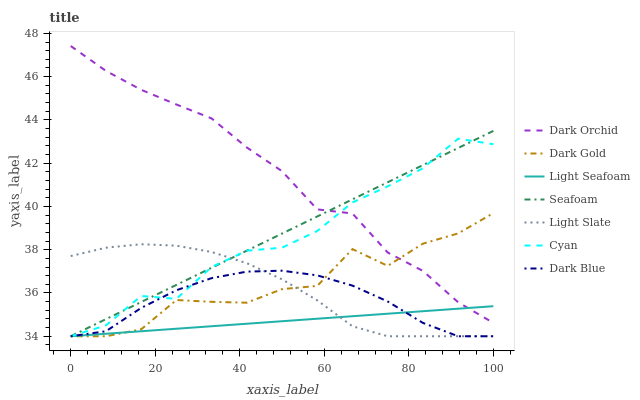Does Light Seafoam have the minimum area under the curve?
Answer yes or no. Yes. Does Dark Orchid have the maximum area under the curve?
Answer yes or no. Yes. Does Light Slate have the minimum area under the curve?
Answer yes or no. No. Does Light Slate have the maximum area under the curve?
Answer yes or no. No. Is Seafoam the smoothest?
Answer yes or no. Yes. Is Dark Gold the roughest?
Answer yes or no. Yes. Is Light Slate the smoothest?
Answer yes or no. No. Is Light Slate the roughest?
Answer yes or no. No. Does Dark Gold have the lowest value?
Answer yes or no. Yes. Does Dark Orchid have the lowest value?
Answer yes or no. No. Does Dark Orchid have the highest value?
Answer yes or no. Yes. Does Light Slate have the highest value?
Answer yes or no. No. Is Dark Blue less than Dark Orchid?
Answer yes or no. Yes. Is Dark Orchid greater than Light Slate?
Answer yes or no. Yes. Does Cyan intersect Light Seafoam?
Answer yes or no. Yes. Is Cyan less than Light Seafoam?
Answer yes or no. No. Is Cyan greater than Light Seafoam?
Answer yes or no. No. Does Dark Blue intersect Dark Orchid?
Answer yes or no. No. 